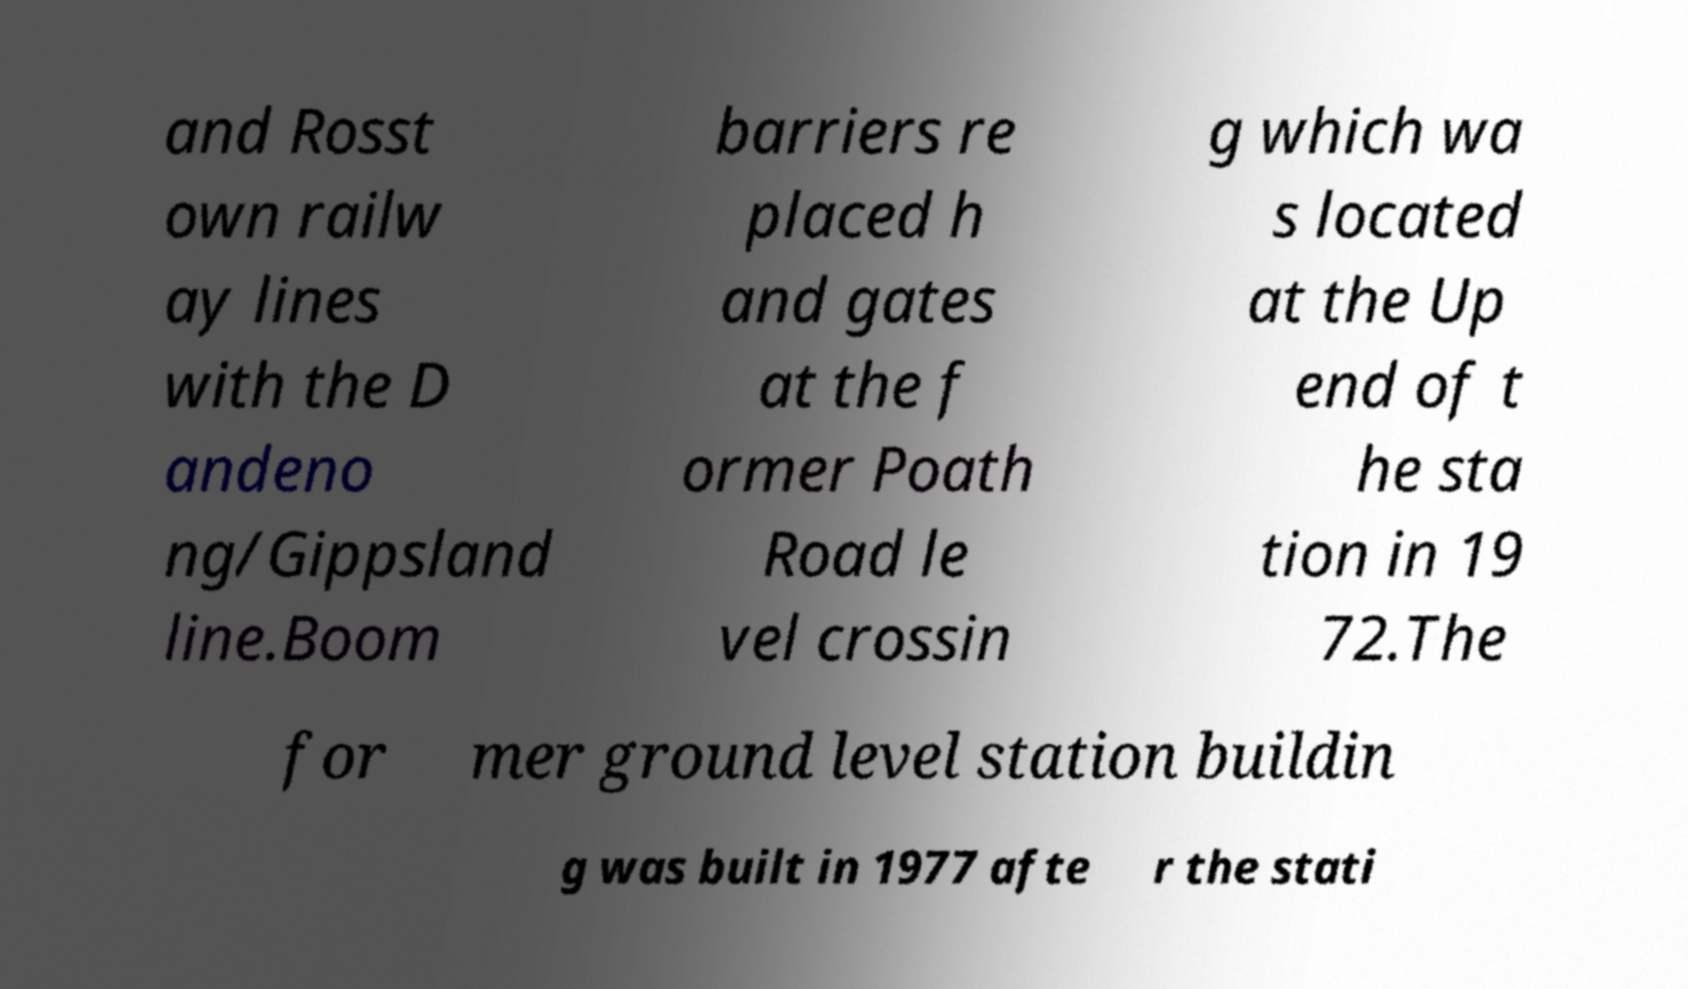For documentation purposes, I need the text within this image transcribed. Could you provide that? and Rosst own railw ay lines with the D andeno ng/Gippsland line.Boom barriers re placed h and gates at the f ormer Poath Road le vel crossin g which wa s located at the Up end of t he sta tion in 19 72.The for mer ground level station buildin g was built in 1977 afte r the stati 